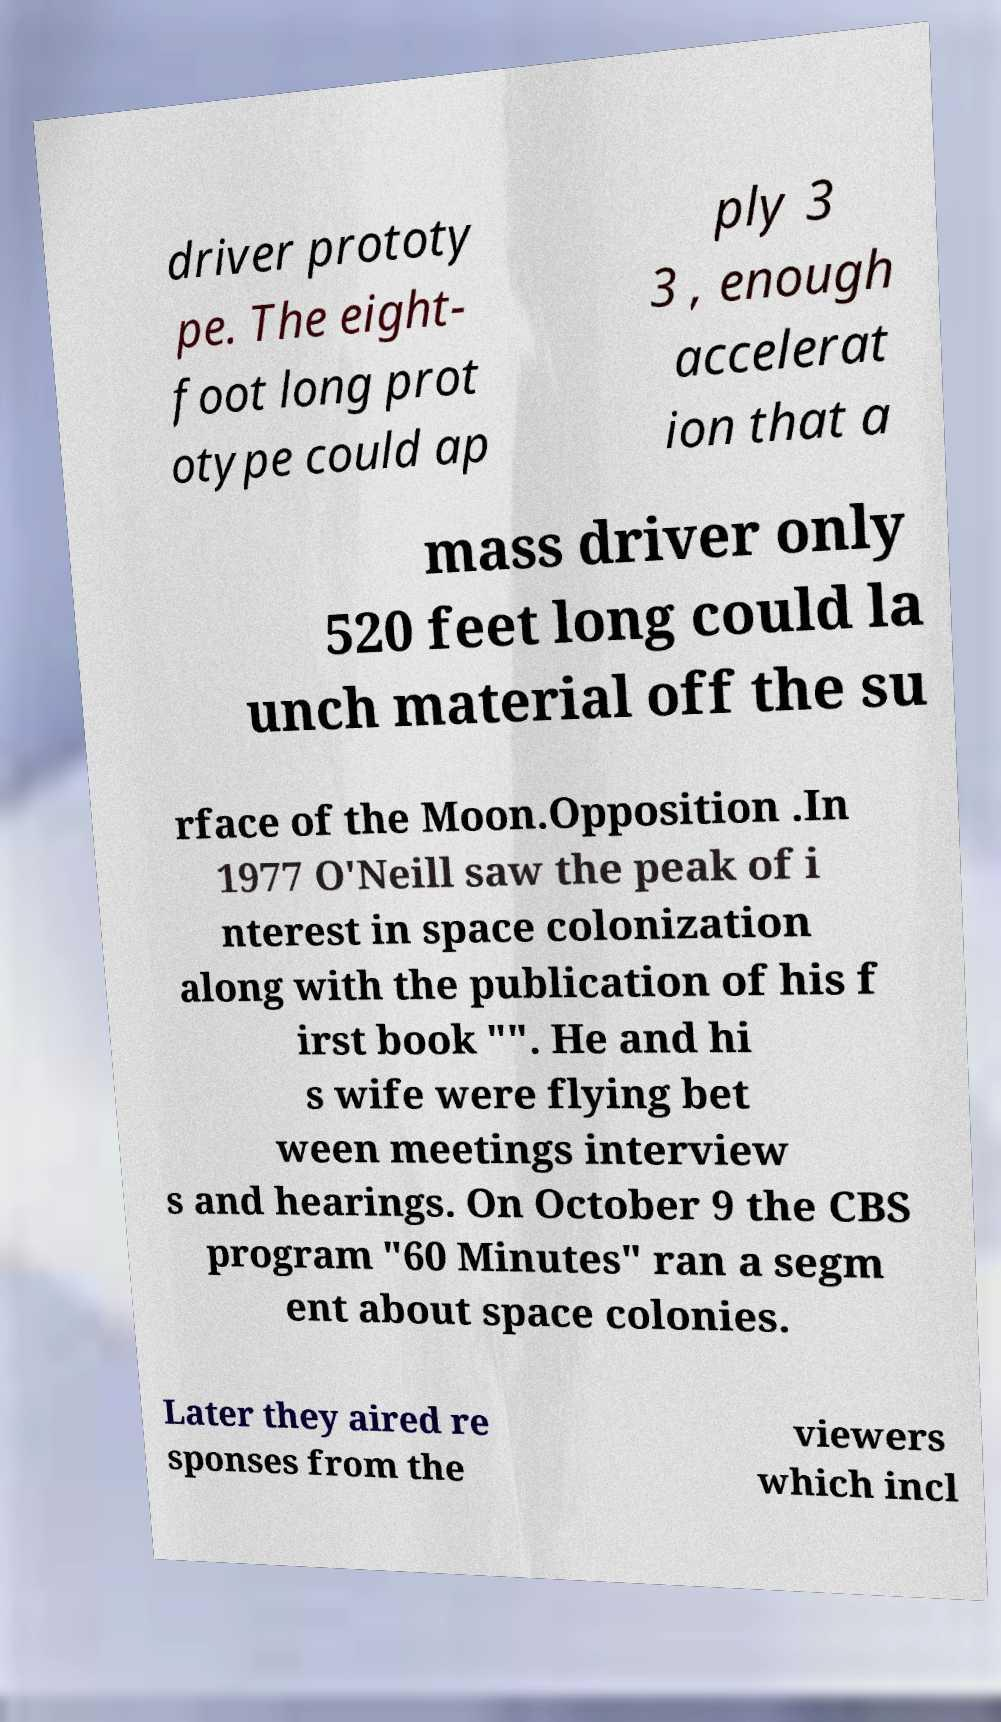Can you accurately transcribe the text from the provided image for me? driver prototy pe. The eight- foot long prot otype could ap ply 3 3 , enough accelerat ion that a mass driver only 520 feet long could la unch material off the su rface of the Moon.Opposition .In 1977 O'Neill saw the peak of i nterest in space colonization along with the publication of his f irst book "". He and hi s wife were flying bet ween meetings interview s and hearings. On October 9 the CBS program "60 Minutes" ran a segm ent about space colonies. Later they aired re sponses from the viewers which incl 